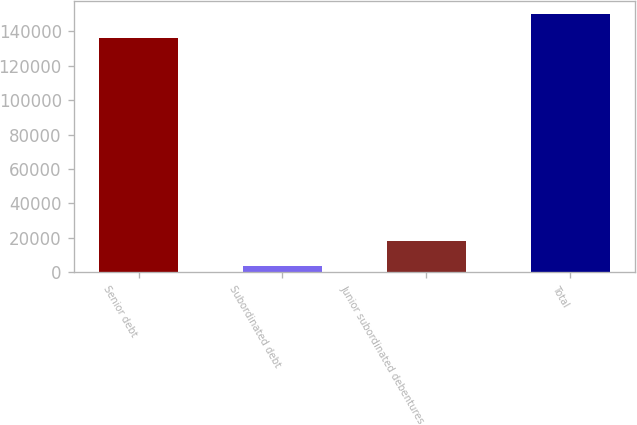Convert chart. <chart><loc_0><loc_0><loc_500><loc_500><bar_chart><fcel>Senior debt<fcel>Subordinated debt<fcel>Junior subordinated debentures<fcel>Total<nl><fcel>136213<fcel>3881<fcel>17990.7<fcel>150323<nl></chart> 